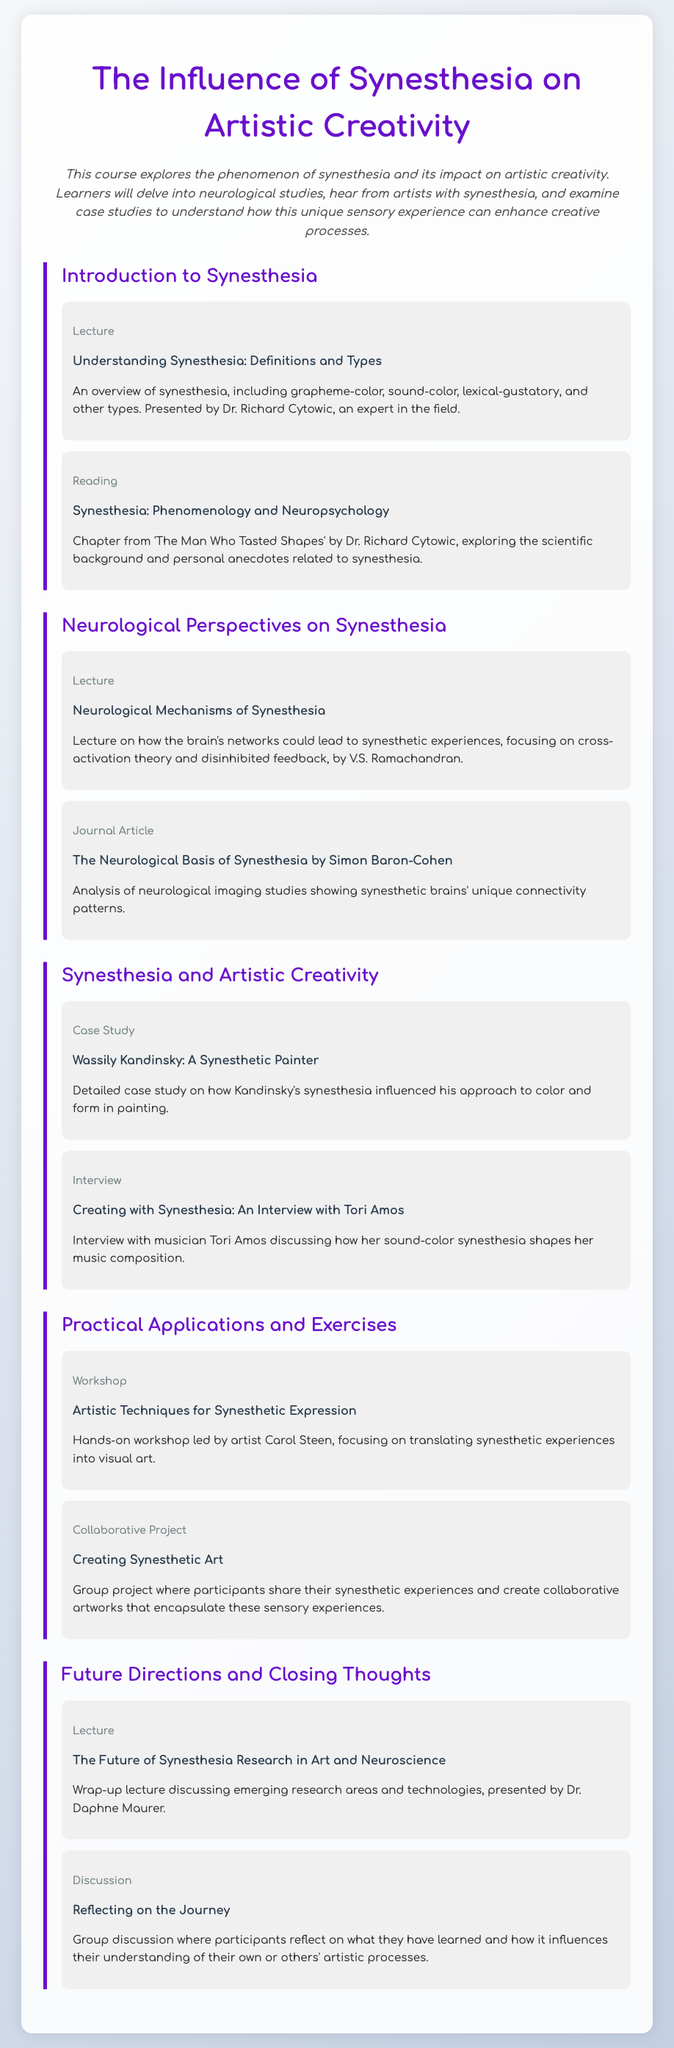what is the main topic of the course? The course focuses on the impact of synesthesia on artistic creativity.
Answer: Synesthesia and artistic creativity who is the instructor for the introduction to synesthesia? Dr. Richard Cytowic presents the overview on synesthesia in the course.
Answer: Dr. Richard Cytowic which artist's synesthesia is explored in a case study? The course includes a case study on Wassily Kandinsky to illustrate synesthesia's influence on art.
Answer: Wassily Kandinsky what type of content is presented in Tori Amos's segment? Tori Amos is featured in an interview where she discusses her synesthetic experiences.
Answer: Interview who leads the workshop on artistic techniques for synesthetic expression? The workshop is led by artist Carol Steen, focusing on creative translation of synesthetic experiences.
Answer: Carol Steen what is the purpose of the collaborative project mentioned in the syllabus? The collaborative project aims for participants to share their synesthetic experiences and create artworks based on them.
Answer: Creating collaborative artworks which module contains a lecture by Dr. Daphne Maurer? The lecture by Dr. Daphne Maurer discussing future research directions is found in the last module.
Answer: Future Directions and Closing Thoughts what is the format of the content about synesthesia in the second module? The second module includes a lecture and a journal article focused on neurological perspectives of synesthesia.
Answer: Lecture and Journal Article how is the course structure organized? The course structure is organized into modules, each containing various types of content.
Answer: Modules 